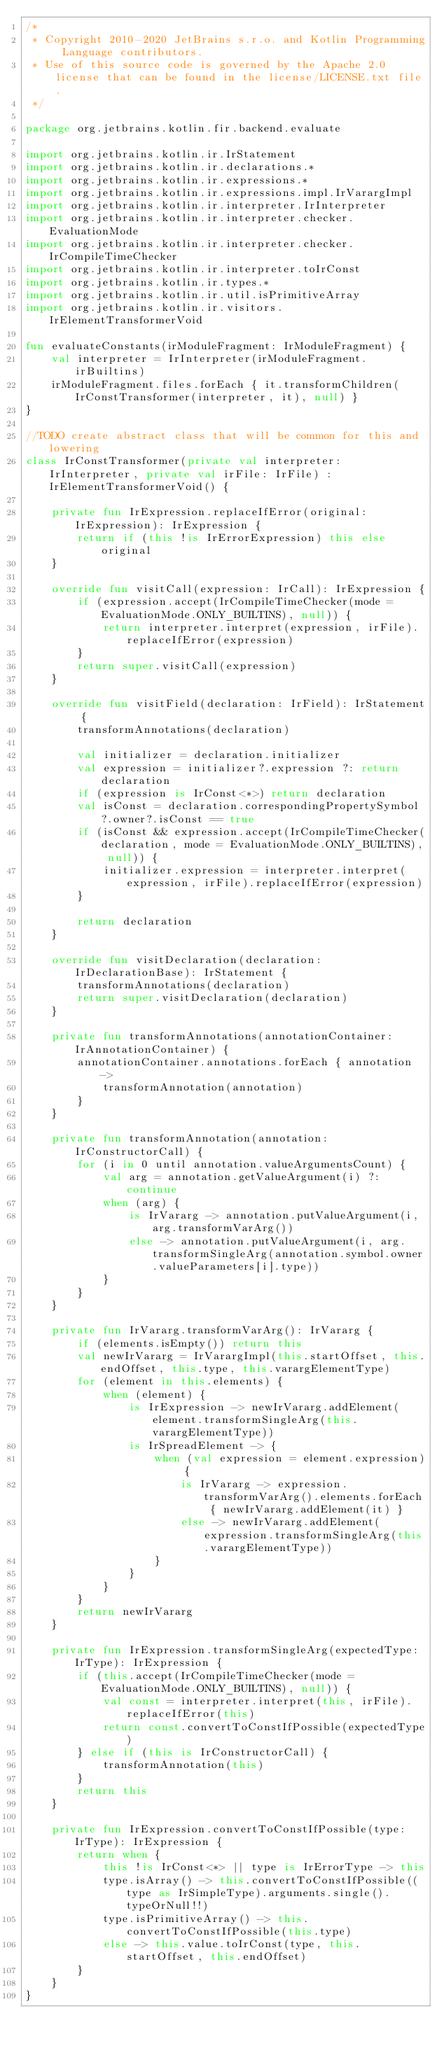Convert code to text. <code><loc_0><loc_0><loc_500><loc_500><_Kotlin_>/*
 * Copyright 2010-2020 JetBrains s.r.o. and Kotlin Programming Language contributors.
 * Use of this source code is governed by the Apache 2.0 license that can be found in the license/LICENSE.txt file.
 */

package org.jetbrains.kotlin.fir.backend.evaluate

import org.jetbrains.kotlin.ir.IrStatement
import org.jetbrains.kotlin.ir.declarations.*
import org.jetbrains.kotlin.ir.expressions.*
import org.jetbrains.kotlin.ir.expressions.impl.IrVarargImpl
import org.jetbrains.kotlin.ir.interpreter.IrInterpreter
import org.jetbrains.kotlin.ir.interpreter.checker.EvaluationMode
import org.jetbrains.kotlin.ir.interpreter.checker.IrCompileTimeChecker
import org.jetbrains.kotlin.ir.interpreter.toIrConst
import org.jetbrains.kotlin.ir.types.*
import org.jetbrains.kotlin.ir.util.isPrimitiveArray
import org.jetbrains.kotlin.ir.visitors.IrElementTransformerVoid

fun evaluateConstants(irModuleFragment: IrModuleFragment) {
    val interpreter = IrInterpreter(irModuleFragment.irBuiltins)
    irModuleFragment.files.forEach { it.transformChildren(IrConstTransformer(interpreter, it), null) }
}

//TODO create abstract class that will be common for this and lowering
class IrConstTransformer(private val interpreter: IrInterpreter, private val irFile: IrFile) : IrElementTransformerVoid() {

    private fun IrExpression.replaceIfError(original: IrExpression): IrExpression {
        return if (this !is IrErrorExpression) this else original
    }

    override fun visitCall(expression: IrCall): IrExpression {
        if (expression.accept(IrCompileTimeChecker(mode = EvaluationMode.ONLY_BUILTINS), null)) {
            return interpreter.interpret(expression, irFile).replaceIfError(expression)
        }
        return super.visitCall(expression)
    }

    override fun visitField(declaration: IrField): IrStatement {
        transformAnnotations(declaration)

        val initializer = declaration.initializer
        val expression = initializer?.expression ?: return declaration
        if (expression is IrConst<*>) return declaration
        val isConst = declaration.correspondingPropertySymbol?.owner?.isConst == true
        if (isConst && expression.accept(IrCompileTimeChecker(declaration, mode = EvaluationMode.ONLY_BUILTINS), null)) {
            initializer.expression = interpreter.interpret(expression, irFile).replaceIfError(expression)
        }

        return declaration
    }

    override fun visitDeclaration(declaration: IrDeclarationBase): IrStatement {
        transformAnnotations(declaration)
        return super.visitDeclaration(declaration)
    }

    private fun transformAnnotations(annotationContainer: IrAnnotationContainer) {
        annotationContainer.annotations.forEach { annotation ->
            transformAnnotation(annotation)
        }
    }

    private fun transformAnnotation(annotation: IrConstructorCall) {
        for (i in 0 until annotation.valueArgumentsCount) {
            val arg = annotation.getValueArgument(i) ?: continue
            when (arg) {
                is IrVararg -> annotation.putValueArgument(i, arg.transformVarArg())
                else -> annotation.putValueArgument(i, arg.transformSingleArg(annotation.symbol.owner.valueParameters[i].type))
            }
        }
    }

    private fun IrVararg.transformVarArg(): IrVararg {
        if (elements.isEmpty()) return this
        val newIrVararg = IrVarargImpl(this.startOffset, this.endOffset, this.type, this.varargElementType)
        for (element in this.elements) {
            when (element) {
                is IrExpression -> newIrVararg.addElement(element.transformSingleArg(this.varargElementType))
                is IrSpreadElement -> {
                    when (val expression = element.expression) {
                        is IrVararg -> expression.transformVarArg().elements.forEach { newIrVararg.addElement(it) }
                        else -> newIrVararg.addElement(expression.transformSingleArg(this.varargElementType))
                    }
                }
            }
        }
        return newIrVararg
    }

    private fun IrExpression.transformSingleArg(expectedType: IrType): IrExpression {
        if (this.accept(IrCompileTimeChecker(mode = EvaluationMode.ONLY_BUILTINS), null)) {
            val const = interpreter.interpret(this, irFile).replaceIfError(this)
            return const.convertToConstIfPossible(expectedType)
        } else if (this is IrConstructorCall) {
            transformAnnotation(this)
        }
        return this
    }

    private fun IrExpression.convertToConstIfPossible(type: IrType): IrExpression {
        return when {
            this !is IrConst<*> || type is IrErrorType -> this
            type.isArray() -> this.convertToConstIfPossible((type as IrSimpleType).arguments.single().typeOrNull!!)
            type.isPrimitiveArray() -> this.convertToConstIfPossible(this.type)
            else -> this.value.toIrConst(type, this.startOffset, this.endOffset)
        }
    }
}
</code> 